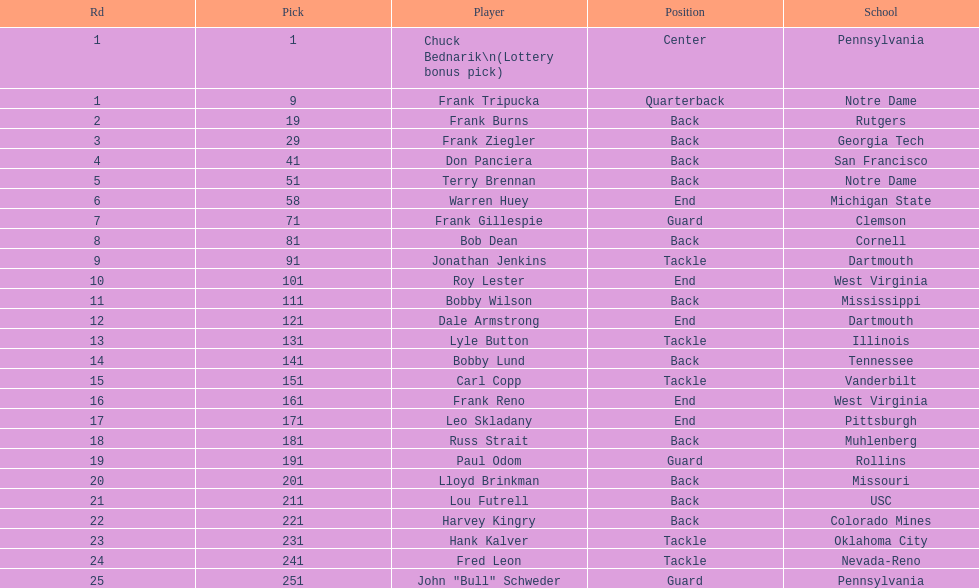What's the maximum rd value? 25. 